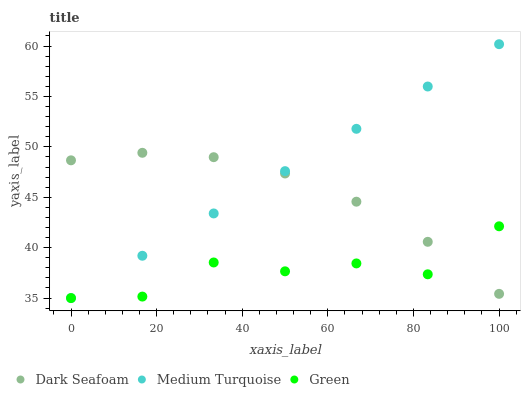Does Green have the minimum area under the curve?
Answer yes or no. Yes. Does Medium Turquoise have the maximum area under the curve?
Answer yes or no. Yes. Does Medium Turquoise have the minimum area under the curve?
Answer yes or no. No. Does Green have the maximum area under the curve?
Answer yes or no. No. Is Medium Turquoise the smoothest?
Answer yes or no. Yes. Is Green the roughest?
Answer yes or no. Yes. Is Green the smoothest?
Answer yes or no. No. Is Medium Turquoise the roughest?
Answer yes or no. No. Does Green have the lowest value?
Answer yes or no. Yes. Does Medium Turquoise have the highest value?
Answer yes or no. Yes. Does Green have the highest value?
Answer yes or no. No. Does Green intersect Medium Turquoise?
Answer yes or no. Yes. Is Green less than Medium Turquoise?
Answer yes or no. No. Is Green greater than Medium Turquoise?
Answer yes or no. No. 